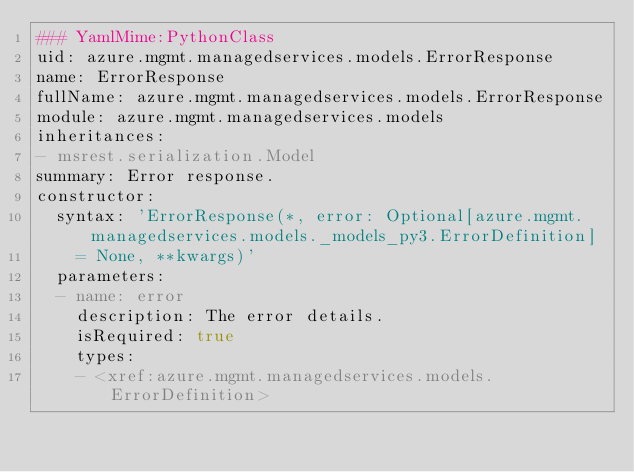<code> <loc_0><loc_0><loc_500><loc_500><_YAML_>### YamlMime:PythonClass
uid: azure.mgmt.managedservices.models.ErrorResponse
name: ErrorResponse
fullName: azure.mgmt.managedservices.models.ErrorResponse
module: azure.mgmt.managedservices.models
inheritances:
- msrest.serialization.Model
summary: Error response.
constructor:
  syntax: 'ErrorResponse(*, error: Optional[azure.mgmt.managedservices.models._models_py3.ErrorDefinition]
    = None, **kwargs)'
  parameters:
  - name: error
    description: The error details.
    isRequired: true
    types:
    - <xref:azure.mgmt.managedservices.models.ErrorDefinition>
</code> 